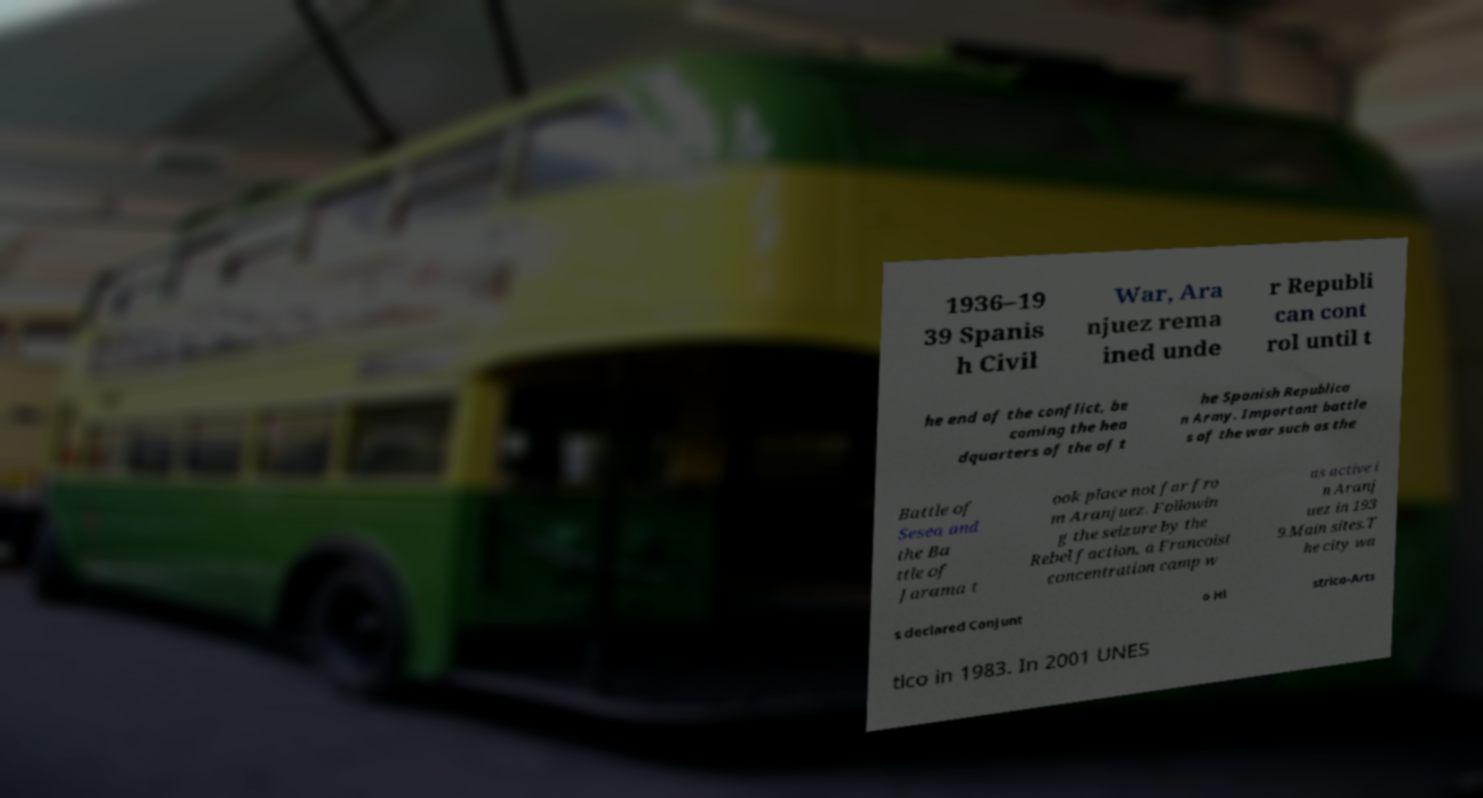Could you extract and type out the text from this image? 1936–19 39 Spanis h Civil War, Ara njuez rema ined unde r Republi can cont rol until t he end of the conflict, be coming the hea dquarters of the of t he Spanish Republica n Army. Important battle s of the war such as the Battle of Sesea and the Ba ttle of Jarama t ook place not far fro m Aranjuez. Followin g the seizure by the Rebel faction, a Francoist concentration camp w as active i n Aranj uez in 193 9.Main sites.T he city wa s declared Conjunt o Hi strico-Arts tico in 1983. In 2001 UNES 